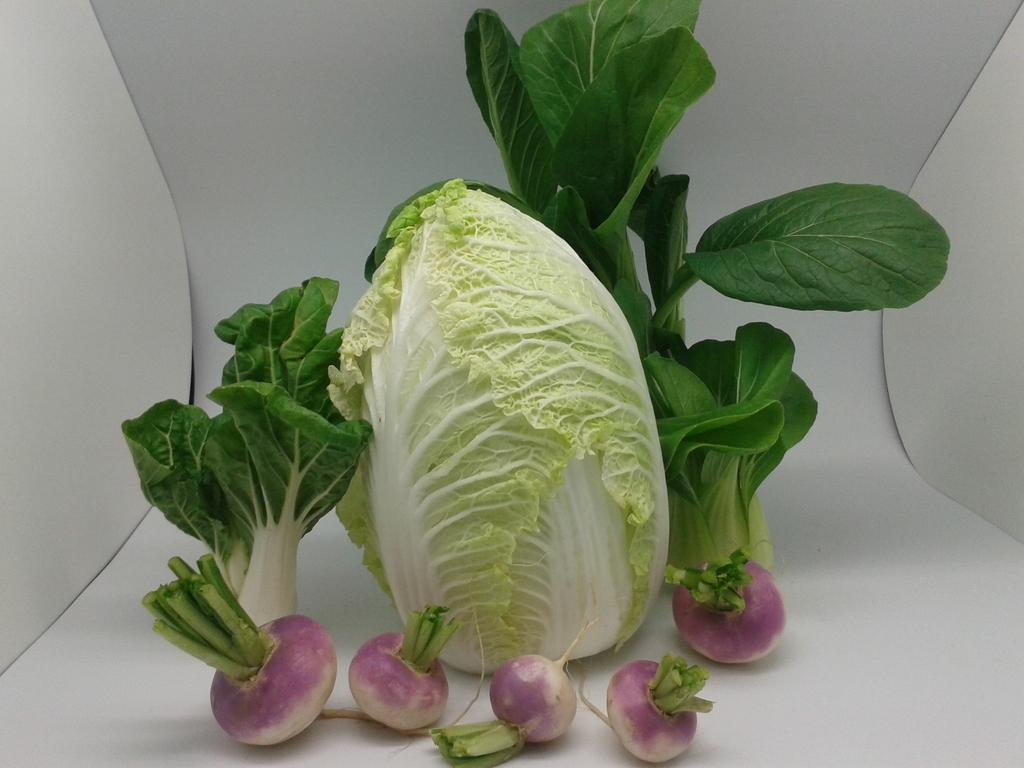What type of vegetables are present in the image? There are cabbages and onions in the image. Where are the cabbages and onions located? The cabbages and onions are placed in a shelf. How many babies are sitting on the shelf with the cabbages and onions? There are no babies present in the image; it only features cabbages and onions in a shelf. 